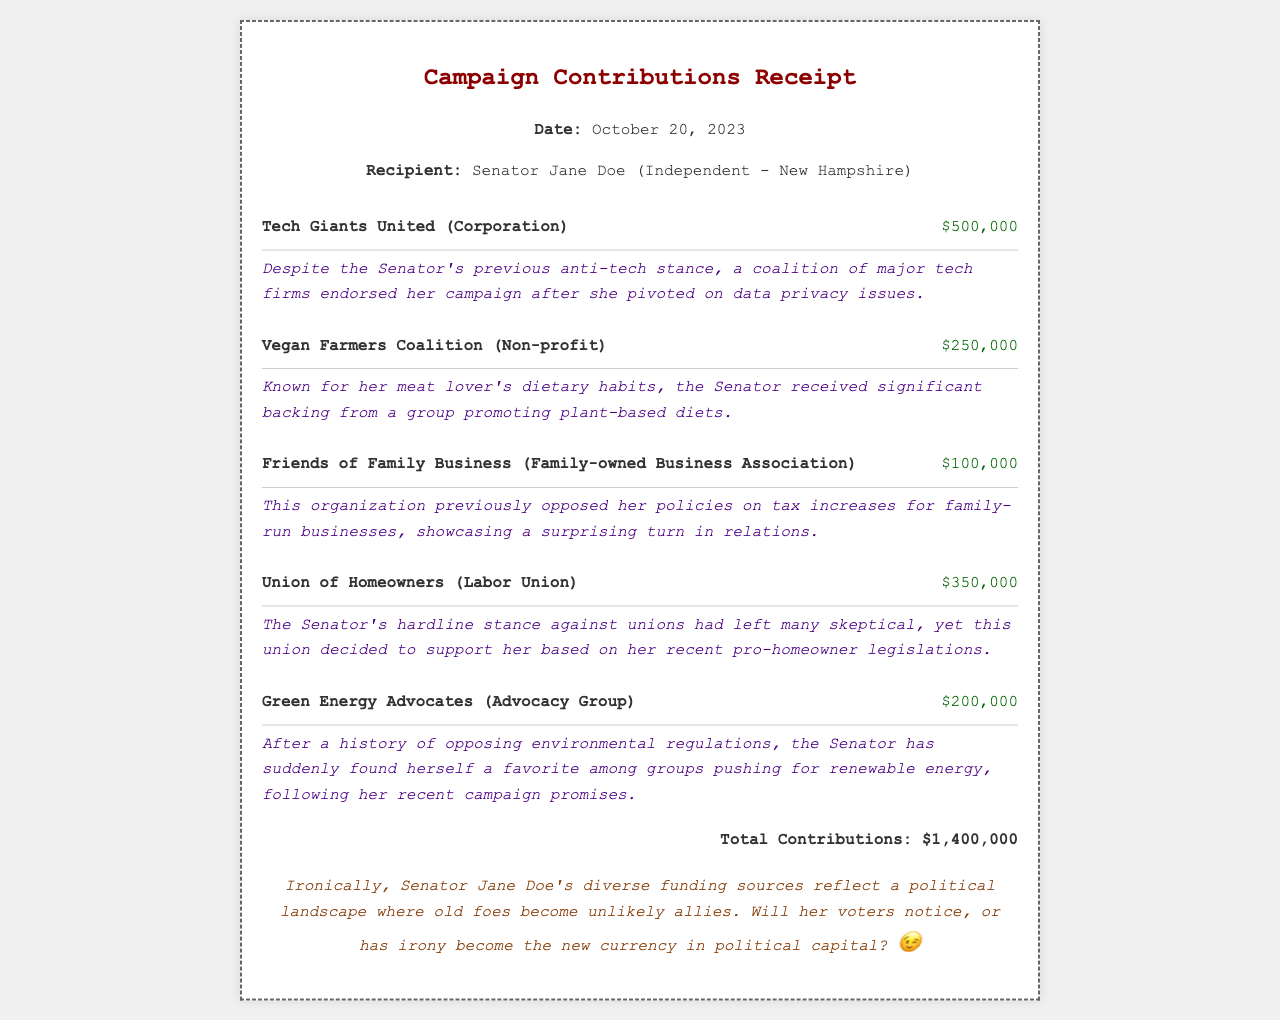What is the date of the receipt? The date of the receipt is explicitly stated in the header of the document.
Answer: October 20, 2023 Who is the recipient of the contributions? The recipient's name and title are stated clearly, identifying who received the contributions.
Answer: Senator Jane Doe What is the total amount of contributions? The total contributions are calculated and summarized at the end of the document.
Answer: $1,400,000 How much did Tech Giants United contribute? The contribution amount is listed alongside the donor's name in the contributions section.
Answer: $500,000 Which donor contributed the least amount? The contributions are sorted by along with their amounts, allowing easy identification of the smallest amount.
Answer: Friends of Family Business What irony is associated with the Vegan Farmers Coalition's contribution? The irony note follows the contribution, explaining the discrepancy between her dietary preferences and the donor's goals.
Answer: Known for her meat lover's dietary habits What unexpected support did the Union of Homeowners provide? The reasoning provided relates to the Senator's prior stance on union policies and their decision to support her.
Answer: Supported her based on her recent pro-homeowner legislations What does the remark at the bottom suggest about political alliances? The remark reflects on the changing political landscape and potential voter awareness regarding funding alignments.
Answer: Ironically, former foes becoming allies What major shift in position led to donations from Green Energy Advocates? The context provided in the irony explains her previous opposition to environmental regulations prior to receiving their support.
Answer: Following her recent campaign promises 